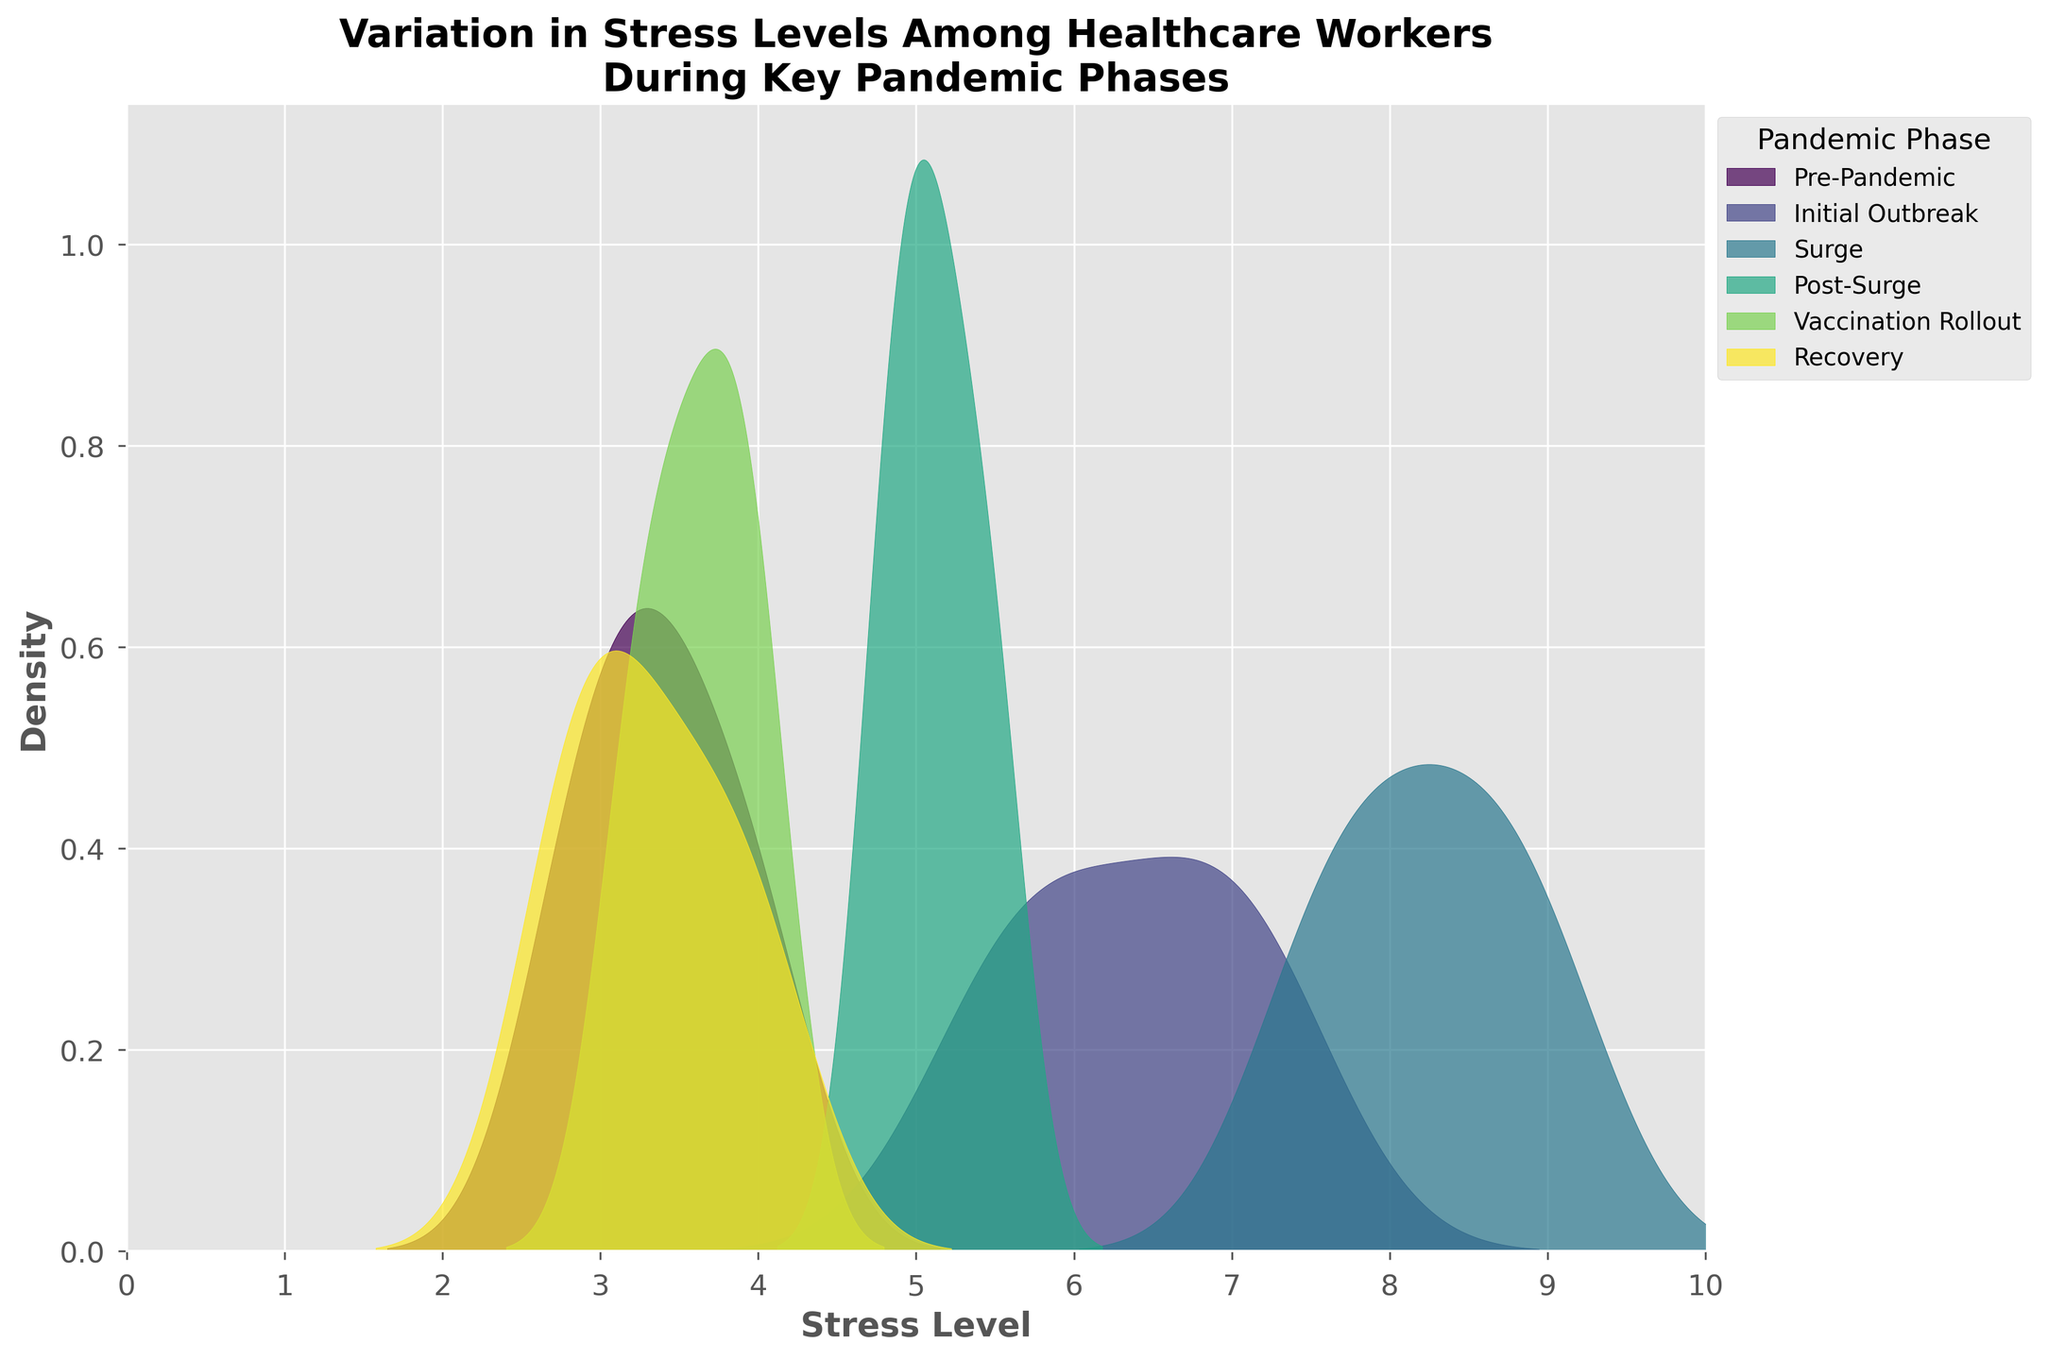What is the title of the figure? The title of the figure is provided at the top and is designed to briefly describe the contents and purpose of the figure.
Answer: Variation in Stress Levels Among Healthcare Workers During Key Pandemic Phases How many different phases are represented in the figure? The different phases represented in the figure are indicated by the legend on the right side of the plot, which lists each phase distinctly.
Answer: Six What is the range of stress levels shown on the x-axis? The x-axis represents the stress levels, and the axis is labeled from 0 to 10, with ticks at each integer.
Answer: 0 to 10 Which phase shows the highest density of stress levels? The phase with the highest density of stress levels can be identified by looking at the peaks of the density curves in the plot.
Answer: Surge During which phase did the stress levels peak most around 5.0? By examining the density plots, identify the phase whose peak is closest to the stress level of 5.0.
Answer: Initial Outbreak Which phase had the lowest stress levels on average? To determine the average stress level, observe the density curves. The phase with the peak closest to lower values will have the lowest average stress levels.
Answer: Pre-Pandemic How does the stress level distribution during the Recovery phase compare to the Pre-Pandemic phase? Compare the density curves of the Recovery and Pre-Pandemic phases. The height and spread of each curve provide insights into how the stress levels differ between the two phases. The Recovery phase is more spread out, indicating a wider distribution of stress levels.
Answer: More spread out Which two phases have overlapping stress level distributions around 3.5? Look for the density plots that intersect or overlap around the 3.5 mark on the x-axis.
Answer: Recovery and Vaccination Rollout What does a higher peak in a density plot indicate in the context of this data? A higher peak in a density plot indicates a higher concentration of data points centered around that stress level value, suggesting many healthcare workers experienced similar levels of stress during that phase.
Answer: Higher concentration of similar stress levels 